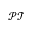<formula> <loc_0><loc_0><loc_500><loc_500>\mathcal { P T }</formula> 